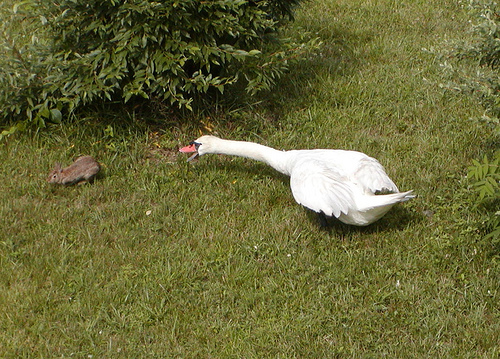<image>
Is there a chipmunk under the bush? No. The chipmunk is not positioned under the bush. The vertical relationship between these objects is different. Is there a duck behind the squirrel? Yes. From this viewpoint, the duck is positioned behind the squirrel, with the squirrel partially or fully occluding the duck. 